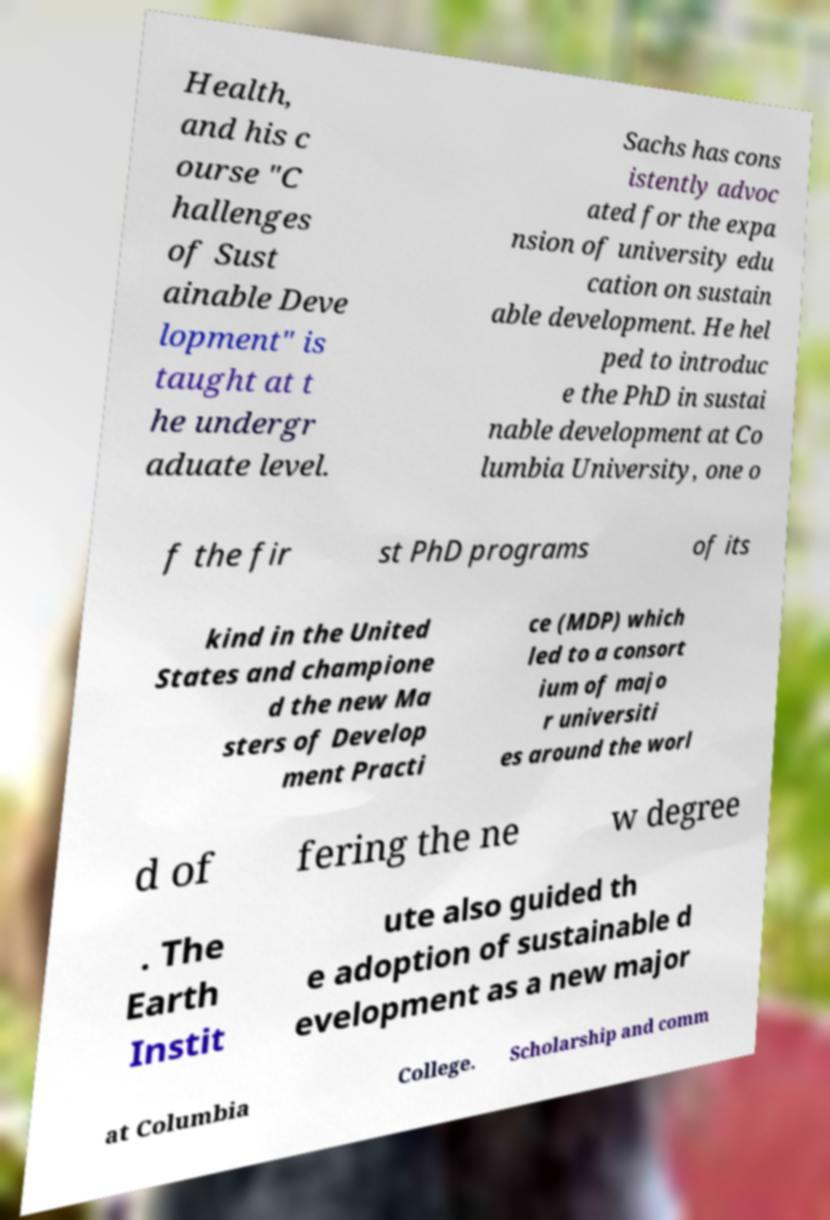Can you read and provide the text displayed in the image?This photo seems to have some interesting text. Can you extract and type it out for me? Health, and his c ourse "C hallenges of Sust ainable Deve lopment" is taught at t he undergr aduate level. Sachs has cons istently advoc ated for the expa nsion of university edu cation on sustain able development. He hel ped to introduc e the PhD in sustai nable development at Co lumbia University, one o f the fir st PhD programs of its kind in the United States and champione d the new Ma sters of Develop ment Practi ce (MDP) which led to a consort ium of majo r universiti es around the worl d of fering the ne w degree . The Earth Instit ute also guided th e adoption of sustainable d evelopment as a new major at Columbia College. Scholarship and comm 